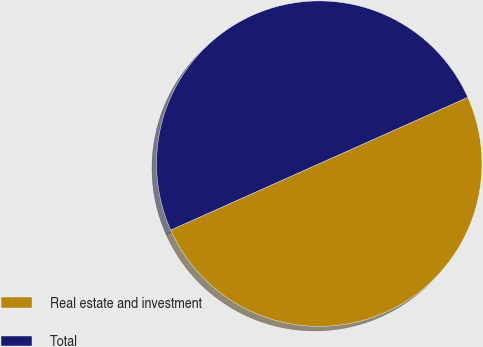Convert chart to OTSL. <chart><loc_0><loc_0><loc_500><loc_500><pie_chart><fcel>Real estate and investment<fcel>Total<nl><fcel>49.99%<fcel>50.01%<nl></chart> 